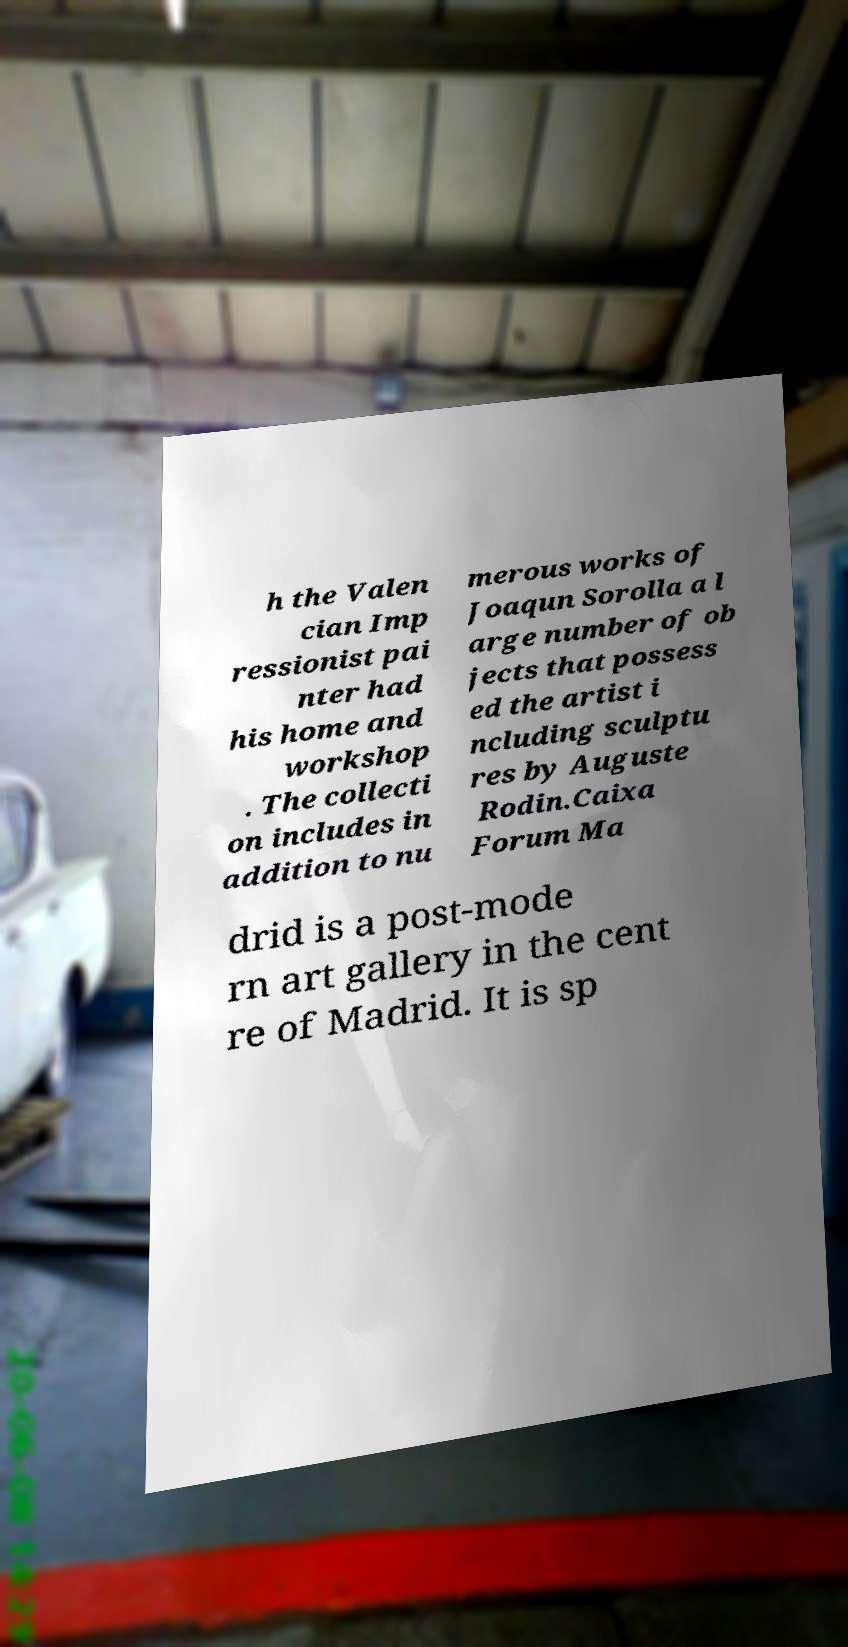For documentation purposes, I need the text within this image transcribed. Could you provide that? h the Valen cian Imp ressionist pai nter had his home and workshop . The collecti on includes in addition to nu merous works of Joaqun Sorolla a l arge number of ob jects that possess ed the artist i ncluding sculptu res by Auguste Rodin.Caixa Forum Ma drid is a post-mode rn art gallery in the cent re of Madrid. It is sp 